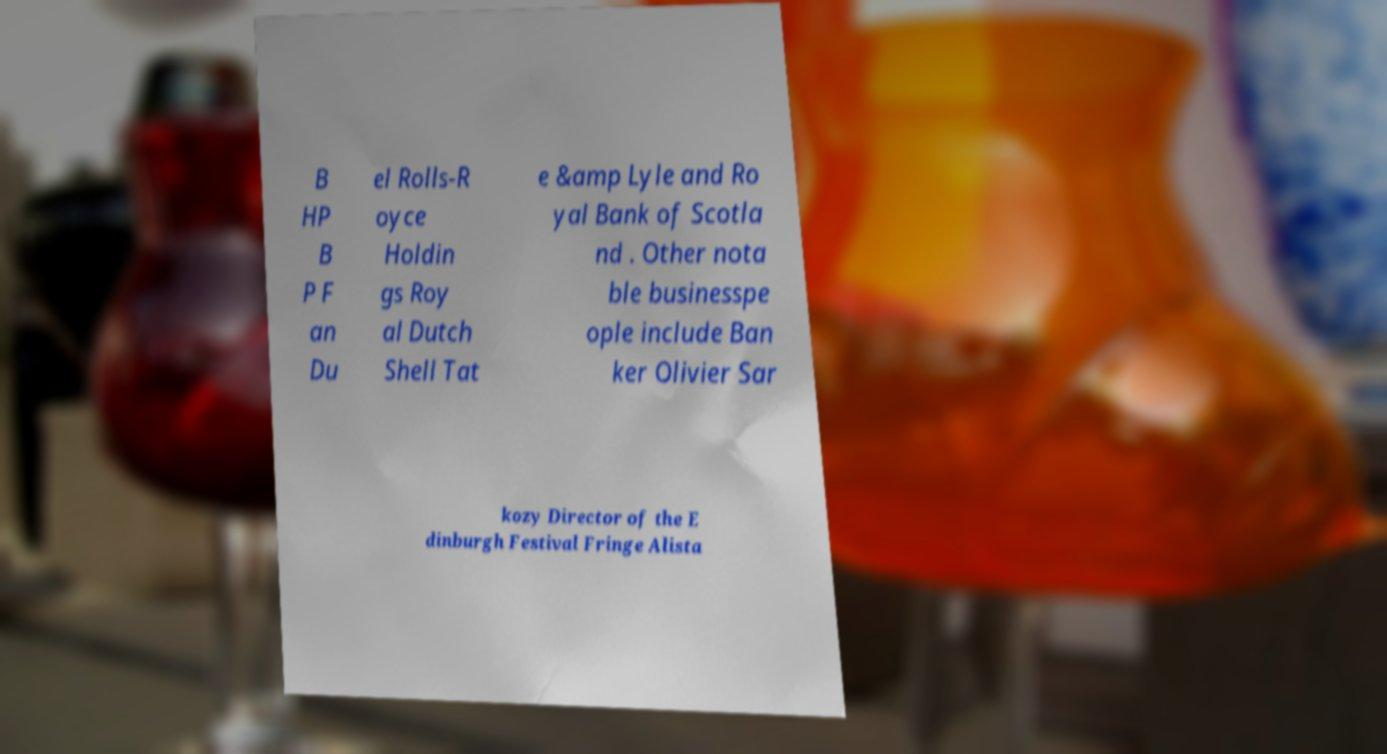Could you extract and type out the text from this image? B HP B P F an Du el Rolls-R oyce Holdin gs Roy al Dutch Shell Tat e &amp Lyle and Ro yal Bank of Scotla nd . Other nota ble businesspe ople include Ban ker Olivier Sar kozy Director of the E dinburgh Festival Fringe Alista 